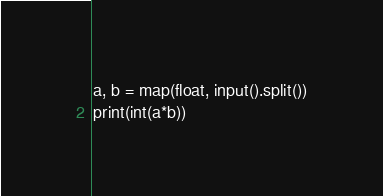<code> <loc_0><loc_0><loc_500><loc_500><_Python_>a, b = map(float, input().split())
print(int(a*b))</code> 